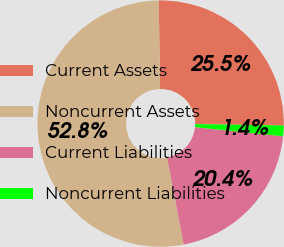Convert chart to OTSL. <chart><loc_0><loc_0><loc_500><loc_500><pie_chart><fcel>Current Assets<fcel>Noncurrent Assets<fcel>Current Liabilities<fcel>Noncurrent Liabilities<nl><fcel>25.49%<fcel>52.75%<fcel>20.35%<fcel>1.4%<nl></chart> 